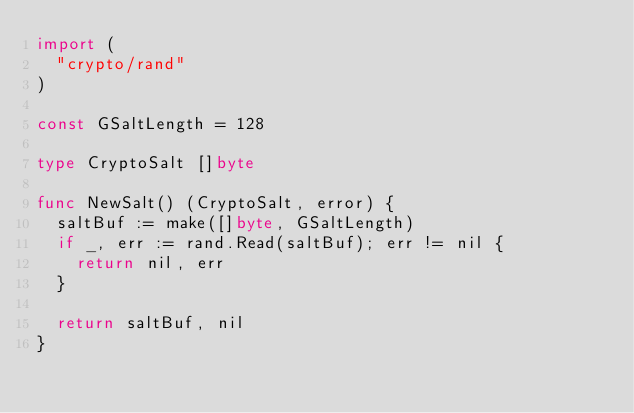<code> <loc_0><loc_0><loc_500><loc_500><_Go_>import (
	"crypto/rand"
)

const GSaltLength = 128

type CryptoSalt []byte

func NewSalt() (CryptoSalt, error) {
	saltBuf := make([]byte, GSaltLength)
	if _, err := rand.Read(saltBuf); err != nil {
		return nil, err
	}

	return saltBuf, nil
}
</code> 